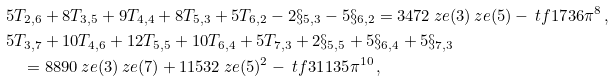Convert formula to latex. <formula><loc_0><loc_0><loc_500><loc_500>& 5 T _ { 2 , 6 } + 8 T _ { 3 , 5 } + 9 T _ { 4 , 4 } + 8 T _ { 5 , 3 } + 5 T _ { 6 , 2 } - 2 \S _ { 5 , 3 } - 5 \S _ { 6 , 2 } = 3 4 7 2 \ z e ( 3 ) \ z e ( 5 ) - \ t f { 1 7 } { 3 6 } \pi ^ { 8 } \, , \\ & 5 T _ { 3 , 7 } + 1 0 T _ { 4 , 6 } + 1 2 T _ { 5 , 5 } + 1 0 T _ { 6 , 4 } + 5 T _ { 7 , 3 } + 2 \S _ { 5 , 5 } + 5 \S _ { 6 , 4 } + 5 \S _ { 7 , 3 } \\ & \quad = 8 8 9 0 \ z e ( 3 ) \ z e ( 7 ) + 1 1 5 3 2 \ z e ( 5 ) ^ { 2 } - \ t f { 3 1 } { 1 3 5 } \pi ^ { 1 0 } \, ,</formula> 